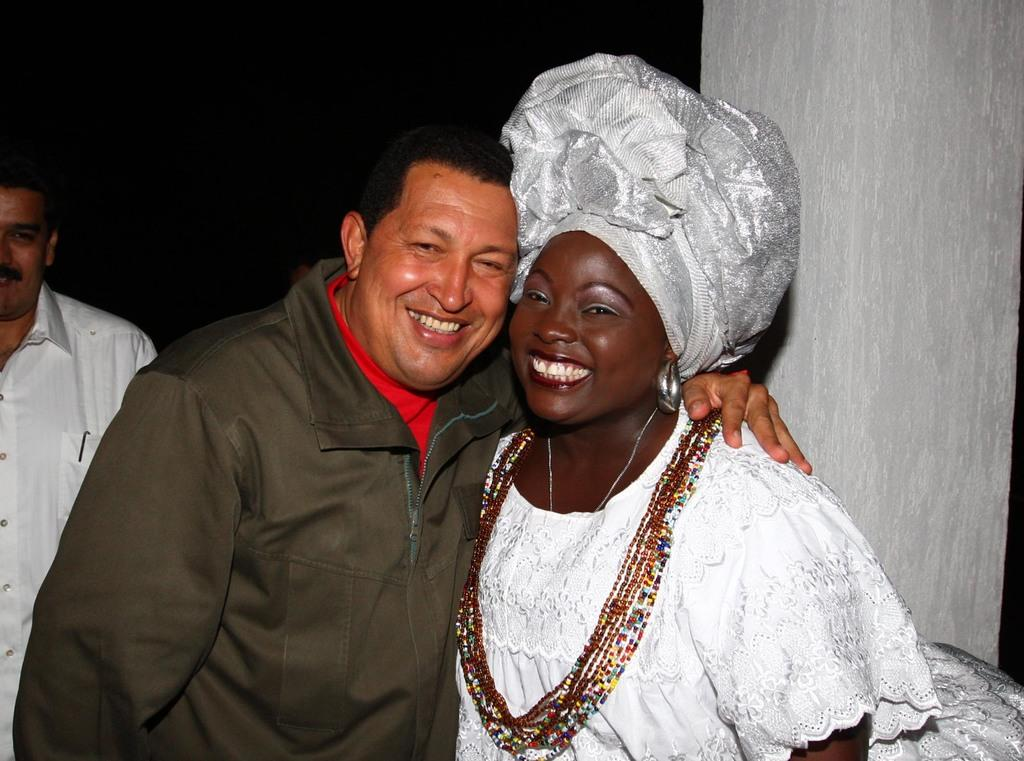How many people are visible in the image? There are two people in the image, both smiling. Is there anyone else in the image besides these two people? Yes, there is another person behind them. What can be seen on the right side of the image? There is a pillar on the right side of the image. How many boys are in the crowd in the image? There is no crowd present in the image, and no boys are mentioned in the provided facts. 